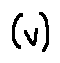<formula> <loc_0><loc_0><loc_500><loc_500>( v )</formula> 